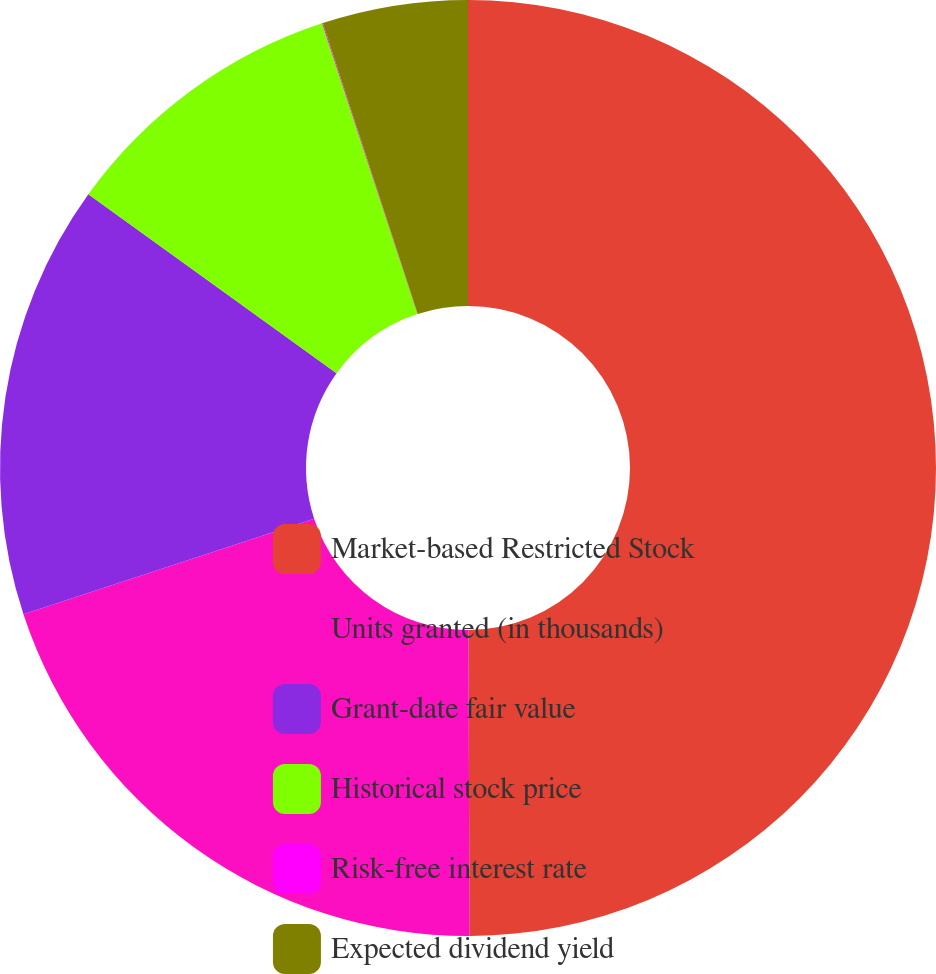Convert chart. <chart><loc_0><loc_0><loc_500><loc_500><pie_chart><fcel>Market-based Restricted Stock<fcel>Units granted (in thousands)<fcel>Grant-date fair value<fcel>Historical stock price<fcel>Risk-free interest rate<fcel>Expected dividend yield<nl><fcel>49.95%<fcel>19.99%<fcel>15.0%<fcel>10.01%<fcel>0.03%<fcel>5.02%<nl></chart> 